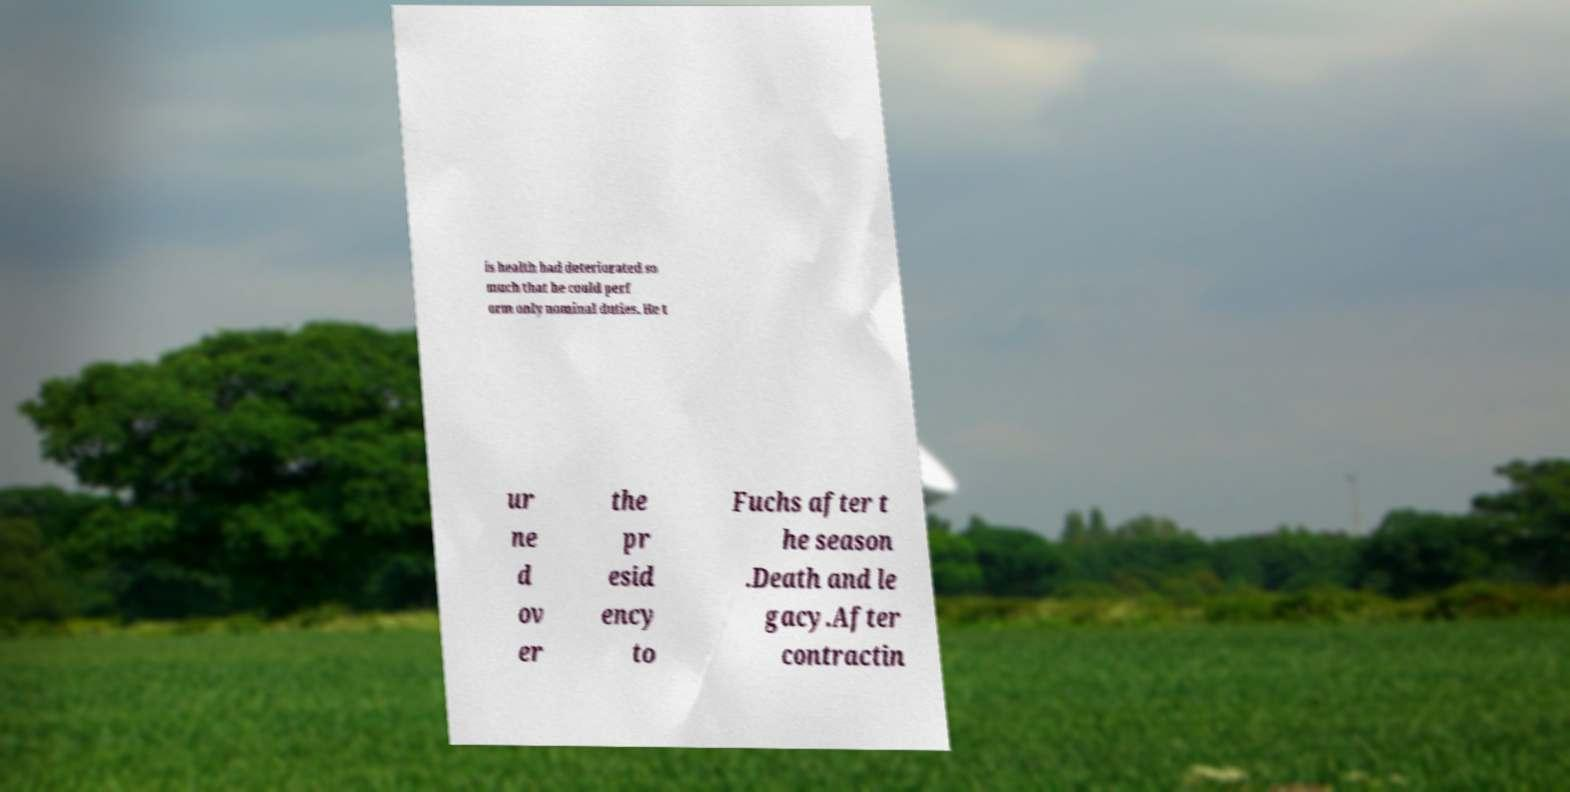Can you accurately transcribe the text from the provided image for me? is health had deteriorated so much that he could perf orm only nominal duties. He t ur ne d ov er the pr esid ency to Fuchs after t he season .Death and le gacy.After contractin 